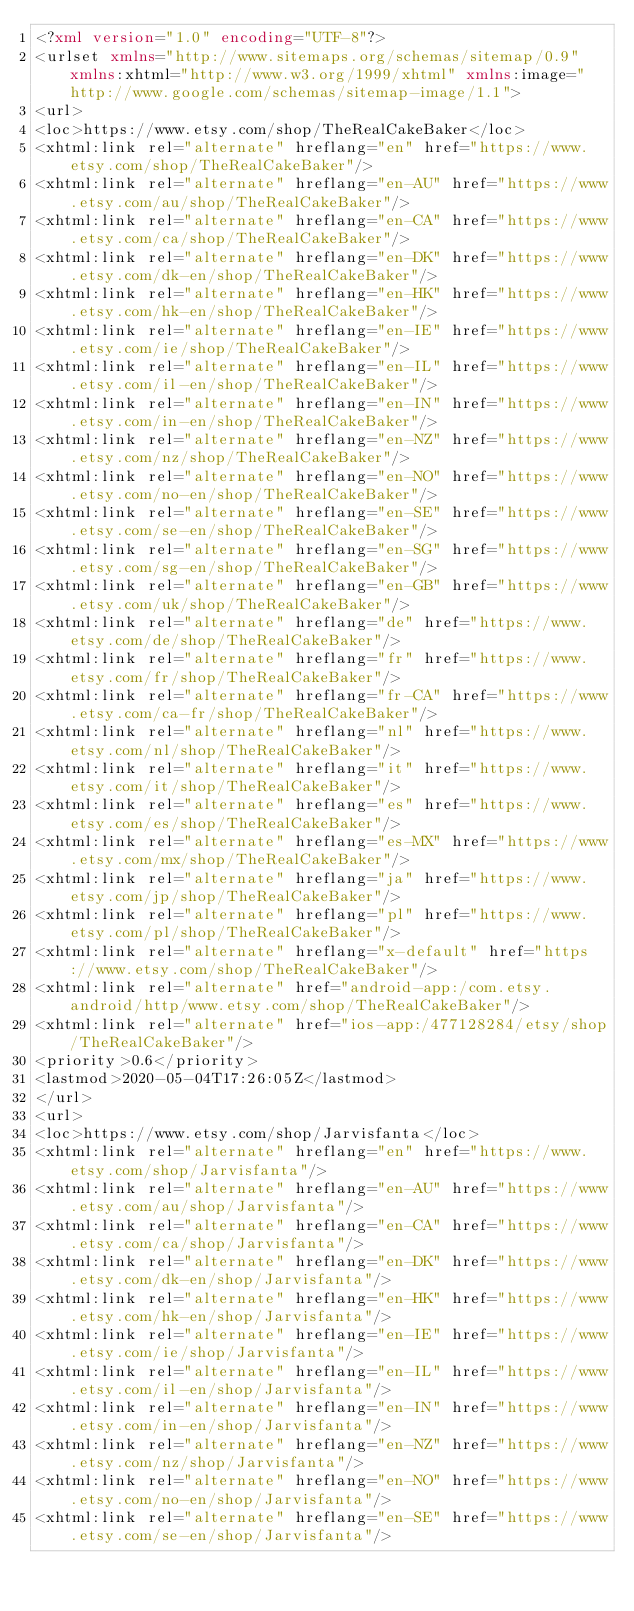Convert code to text. <code><loc_0><loc_0><loc_500><loc_500><_XML_><?xml version="1.0" encoding="UTF-8"?>
<urlset xmlns="http://www.sitemaps.org/schemas/sitemap/0.9" xmlns:xhtml="http://www.w3.org/1999/xhtml" xmlns:image="http://www.google.com/schemas/sitemap-image/1.1">
<url>
<loc>https://www.etsy.com/shop/TheRealCakeBaker</loc>
<xhtml:link rel="alternate" hreflang="en" href="https://www.etsy.com/shop/TheRealCakeBaker"/>
<xhtml:link rel="alternate" hreflang="en-AU" href="https://www.etsy.com/au/shop/TheRealCakeBaker"/>
<xhtml:link rel="alternate" hreflang="en-CA" href="https://www.etsy.com/ca/shop/TheRealCakeBaker"/>
<xhtml:link rel="alternate" hreflang="en-DK" href="https://www.etsy.com/dk-en/shop/TheRealCakeBaker"/>
<xhtml:link rel="alternate" hreflang="en-HK" href="https://www.etsy.com/hk-en/shop/TheRealCakeBaker"/>
<xhtml:link rel="alternate" hreflang="en-IE" href="https://www.etsy.com/ie/shop/TheRealCakeBaker"/>
<xhtml:link rel="alternate" hreflang="en-IL" href="https://www.etsy.com/il-en/shop/TheRealCakeBaker"/>
<xhtml:link rel="alternate" hreflang="en-IN" href="https://www.etsy.com/in-en/shop/TheRealCakeBaker"/>
<xhtml:link rel="alternate" hreflang="en-NZ" href="https://www.etsy.com/nz/shop/TheRealCakeBaker"/>
<xhtml:link rel="alternate" hreflang="en-NO" href="https://www.etsy.com/no-en/shop/TheRealCakeBaker"/>
<xhtml:link rel="alternate" hreflang="en-SE" href="https://www.etsy.com/se-en/shop/TheRealCakeBaker"/>
<xhtml:link rel="alternate" hreflang="en-SG" href="https://www.etsy.com/sg-en/shop/TheRealCakeBaker"/>
<xhtml:link rel="alternate" hreflang="en-GB" href="https://www.etsy.com/uk/shop/TheRealCakeBaker"/>
<xhtml:link rel="alternate" hreflang="de" href="https://www.etsy.com/de/shop/TheRealCakeBaker"/>
<xhtml:link rel="alternate" hreflang="fr" href="https://www.etsy.com/fr/shop/TheRealCakeBaker"/>
<xhtml:link rel="alternate" hreflang="fr-CA" href="https://www.etsy.com/ca-fr/shop/TheRealCakeBaker"/>
<xhtml:link rel="alternate" hreflang="nl" href="https://www.etsy.com/nl/shop/TheRealCakeBaker"/>
<xhtml:link rel="alternate" hreflang="it" href="https://www.etsy.com/it/shop/TheRealCakeBaker"/>
<xhtml:link rel="alternate" hreflang="es" href="https://www.etsy.com/es/shop/TheRealCakeBaker"/>
<xhtml:link rel="alternate" hreflang="es-MX" href="https://www.etsy.com/mx/shop/TheRealCakeBaker"/>
<xhtml:link rel="alternate" hreflang="ja" href="https://www.etsy.com/jp/shop/TheRealCakeBaker"/>
<xhtml:link rel="alternate" hreflang="pl" href="https://www.etsy.com/pl/shop/TheRealCakeBaker"/>
<xhtml:link rel="alternate" hreflang="x-default" href="https://www.etsy.com/shop/TheRealCakeBaker"/>
<xhtml:link rel="alternate" href="android-app:/com.etsy.android/http/www.etsy.com/shop/TheRealCakeBaker"/>
<xhtml:link rel="alternate" href="ios-app:/477128284/etsy/shop/TheRealCakeBaker"/>
<priority>0.6</priority>
<lastmod>2020-05-04T17:26:05Z</lastmod>
</url>
<url>
<loc>https://www.etsy.com/shop/Jarvisfanta</loc>
<xhtml:link rel="alternate" hreflang="en" href="https://www.etsy.com/shop/Jarvisfanta"/>
<xhtml:link rel="alternate" hreflang="en-AU" href="https://www.etsy.com/au/shop/Jarvisfanta"/>
<xhtml:link rel="alternate" hreflang="en-CA" href="https://www.etsy.com/ca/shop/Jarvisfanta"/>
<xhtml:link rel="alternate" hreflang="en-DK" href="https://www.etsy.com/dk-en/shop/Jarvisfanta"/>
<xhtml:link rel="alternate" hreflang="en-HK" href="https://www.etsy.com/hk-en/shop/Jarvisfanta"/>
<xhtml:link rel="alternate" hreflang="en-IE" href="https://www.etsy.com/ie/shop/Jarvisfanta"/>
<xhtml:link rel="alternate" hreflang="en-IL" href="https://www.etsy.com/il-en/shop/Jarvisfanta"/>
<xhtml:link rel="alternate" hreflang="en-IN" href="https://www.etsy.com/in-en/shop/Jarvisfanta"/>
<xhtml:link rel="alternate" hreflang="en-NZ" href="https://www.etsy.com/nz/shop/Jarvisfanta"/>
<xhtml:link rel="alternate" hreflang="en-NO" href="https://www.etsy.com/no-en/shop/Jarvisfanta"/>
<xhtml:link rel="alternate" hreflang="en-SE" href="https://www.etsy.com/se-en/shop/Jarvisfanta"/></code> 